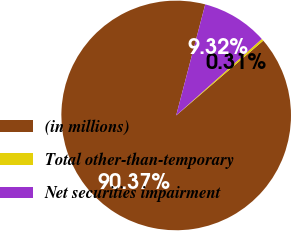Convert chart. <chart><loc_0><loc_0><loc_500><loc_500><pie_chart><fcel>(in millions)<fcel>Total other-than-temporary<fcel>Net securities impairment<nl><fcel>90.37%<fcel>0.31%<fcel>9.32%<nl></chart> 